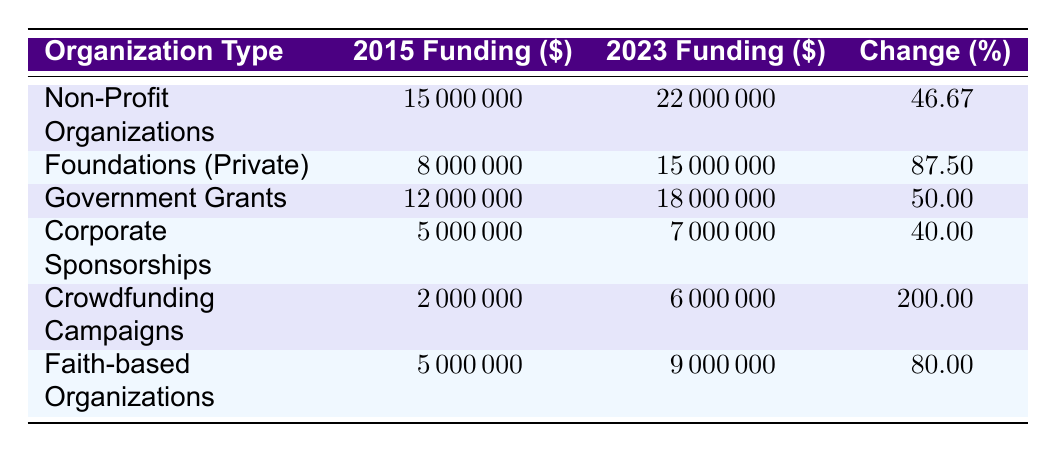What was the funding amount for Non-Profit Organizations in 2015? The table shows that Non-Profit Organizations received 15,000,000 dollars in funding in 2015.
Answer: 15,000,000 Which organization type experienced the highest percentage change in funding from 2015 to 2023? By comparing the percentage changes listed in the table, Crowdfunding Campaigns had the highest percentage change with 200.00 percent.
Answer: Crowdfunding Campaigns What was the total funding amount for all organization types in 2023? The funding amounts in 2023 for each organization type are 22,000,000 (Non-Profit), 15,000,000 (Foundations), 18,000,000 (Government), 7,000,000 (Corporate), 6,000,000 (Crowdfunding), and 9,000,000 (Faith-based). Adding these amounts gives a total of 22,000,000 + 15,000,000 + 18,000,000 + 7,000,000 + 6,000,000 + 9,000,000 = 77,000,000 dollars.
Answer: 77,000,000 Is there any organization type that received less funding in 2023 compared to in 2015? By examining the funding amounts in both years for each organization type, all types show an increase in funding from 2015 to 2023. Therefore, the answer is no.
Answer: No What is the difference in funding for Foundations (Private) between 2015 and 2023? The funding amount for Foundations (Private) in 2015 was 8,000,000 dollars and in 2023 it was 15,000,000 dollars. To find the difference, we calculate 15,000,000 - 8,000,000 = 7,000,000 dollars.
Answer: 7,000,000 What organization type had a funding amount of 5,000,000 dollars in 2015? The table indicates that both Corporate Sponsorships and Faith-based Organizations had a funding amount of 5,000,000 dollars in 2015.
Answer: Corporate Sponsorships and Faith-based Organizations Which organization type doubled its funding amount from 2015 to 2023? Looking through the table, Crowdfunding Campaigns received 2,000,000 dollars in 2015 and had 6,000,000 dollars in 2023. This represents a threefold increase, which is not a double of the original. No organization achieved exactly double, but Crowdfunding Campaigns comes close as it had a 200 percent increase.
Answer: None What was the average percentage change in funding across all organization types? To find the average percentage change, we sum all the percentage changes: 46.67 + 87.5 + 50 + 40 + 200 + 80 = 504.17. Then, we divide this sum by the number of organization types (which is 6): 504.17 / 6 = 84.03 percent.
Answer: 84.03 